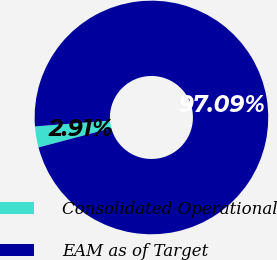<chart> <loc_0><loc_0><loc_500><loc_500><pie_chart><fcel>Consolidated Operational<fcel>EAM as of Target<nl><fcel>2.91%<fcel>97.09%<nl></chart> 